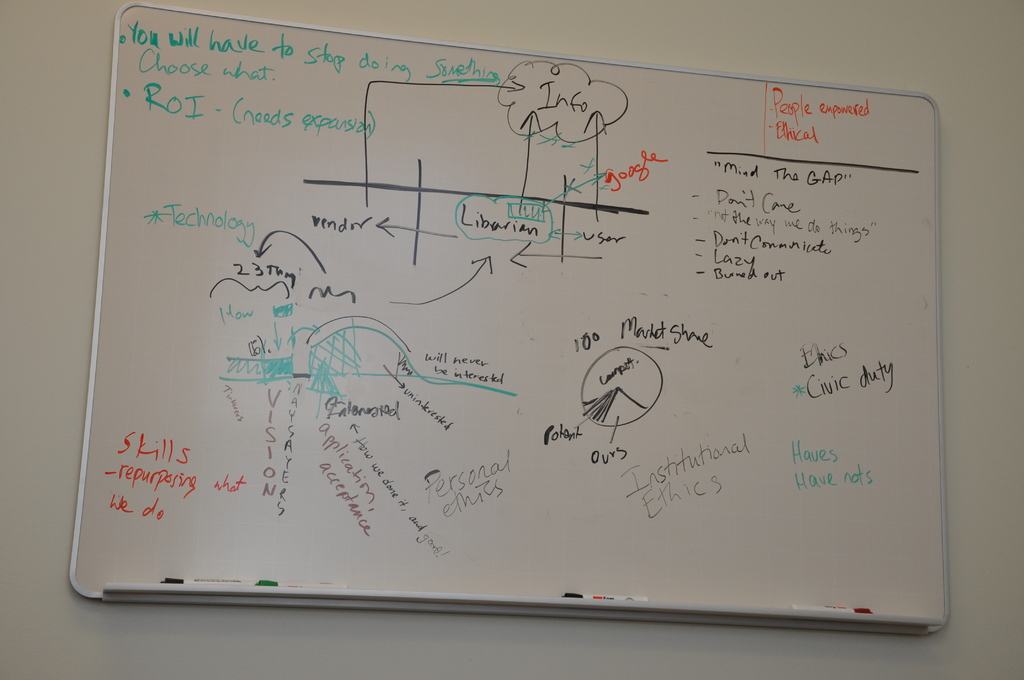Can you explain the significance of 'ROI' as it appears on the whiteboard? The mention of 'ROI' or Return on Investment on the whiteboard highlights a key business consideration. It suggests that the discussion is focusing on the evaluation of different projects or initiatives in terms of the value or return they generate relative to the resources invested. This is crucial for prioritizing projects effectively, ensuring that the most beneficial outcomes for the company are achieved efficiently. 